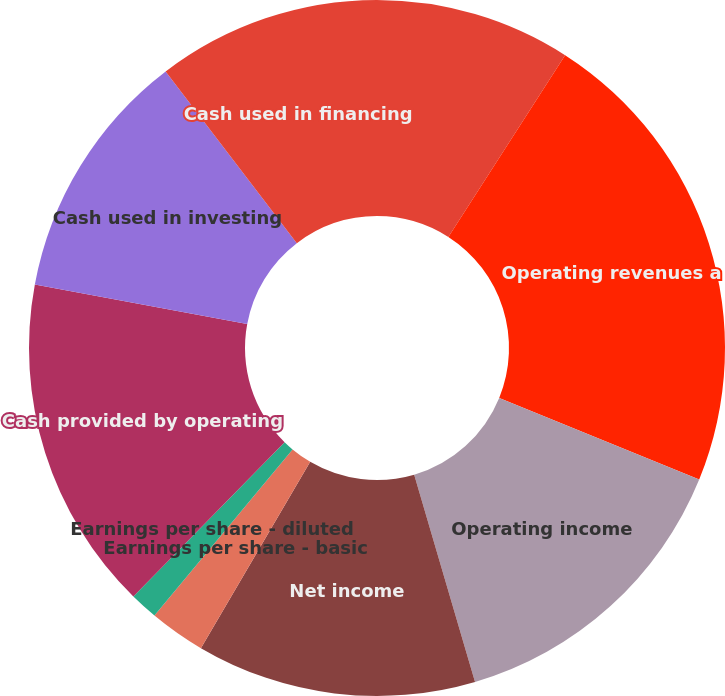Convert chart to OTSL. <chart><loc_0><loc_0><loc_500><loc_500><pie_chart><fcel>Millions Except per Share<fcel>Operating revenues a<fcel>Operating income<fcel>Net income<fcel>Earnings per share - basic<fcel>Earnings per share - diluted<fcel>Dividends declared per share<fcel>Cash provided by operating<fcel>Cash used in investing<fcel>Cash used in financing<nl><fcel>9.09%<fcel>22.08%<fcel>14.29%<fcel>12.99%<fcel>2.6%<fcel>1.3%<fcel>0.0%<fcel>15.58%<fcel>11.69%<fcel>10.39%<nl></chart> 